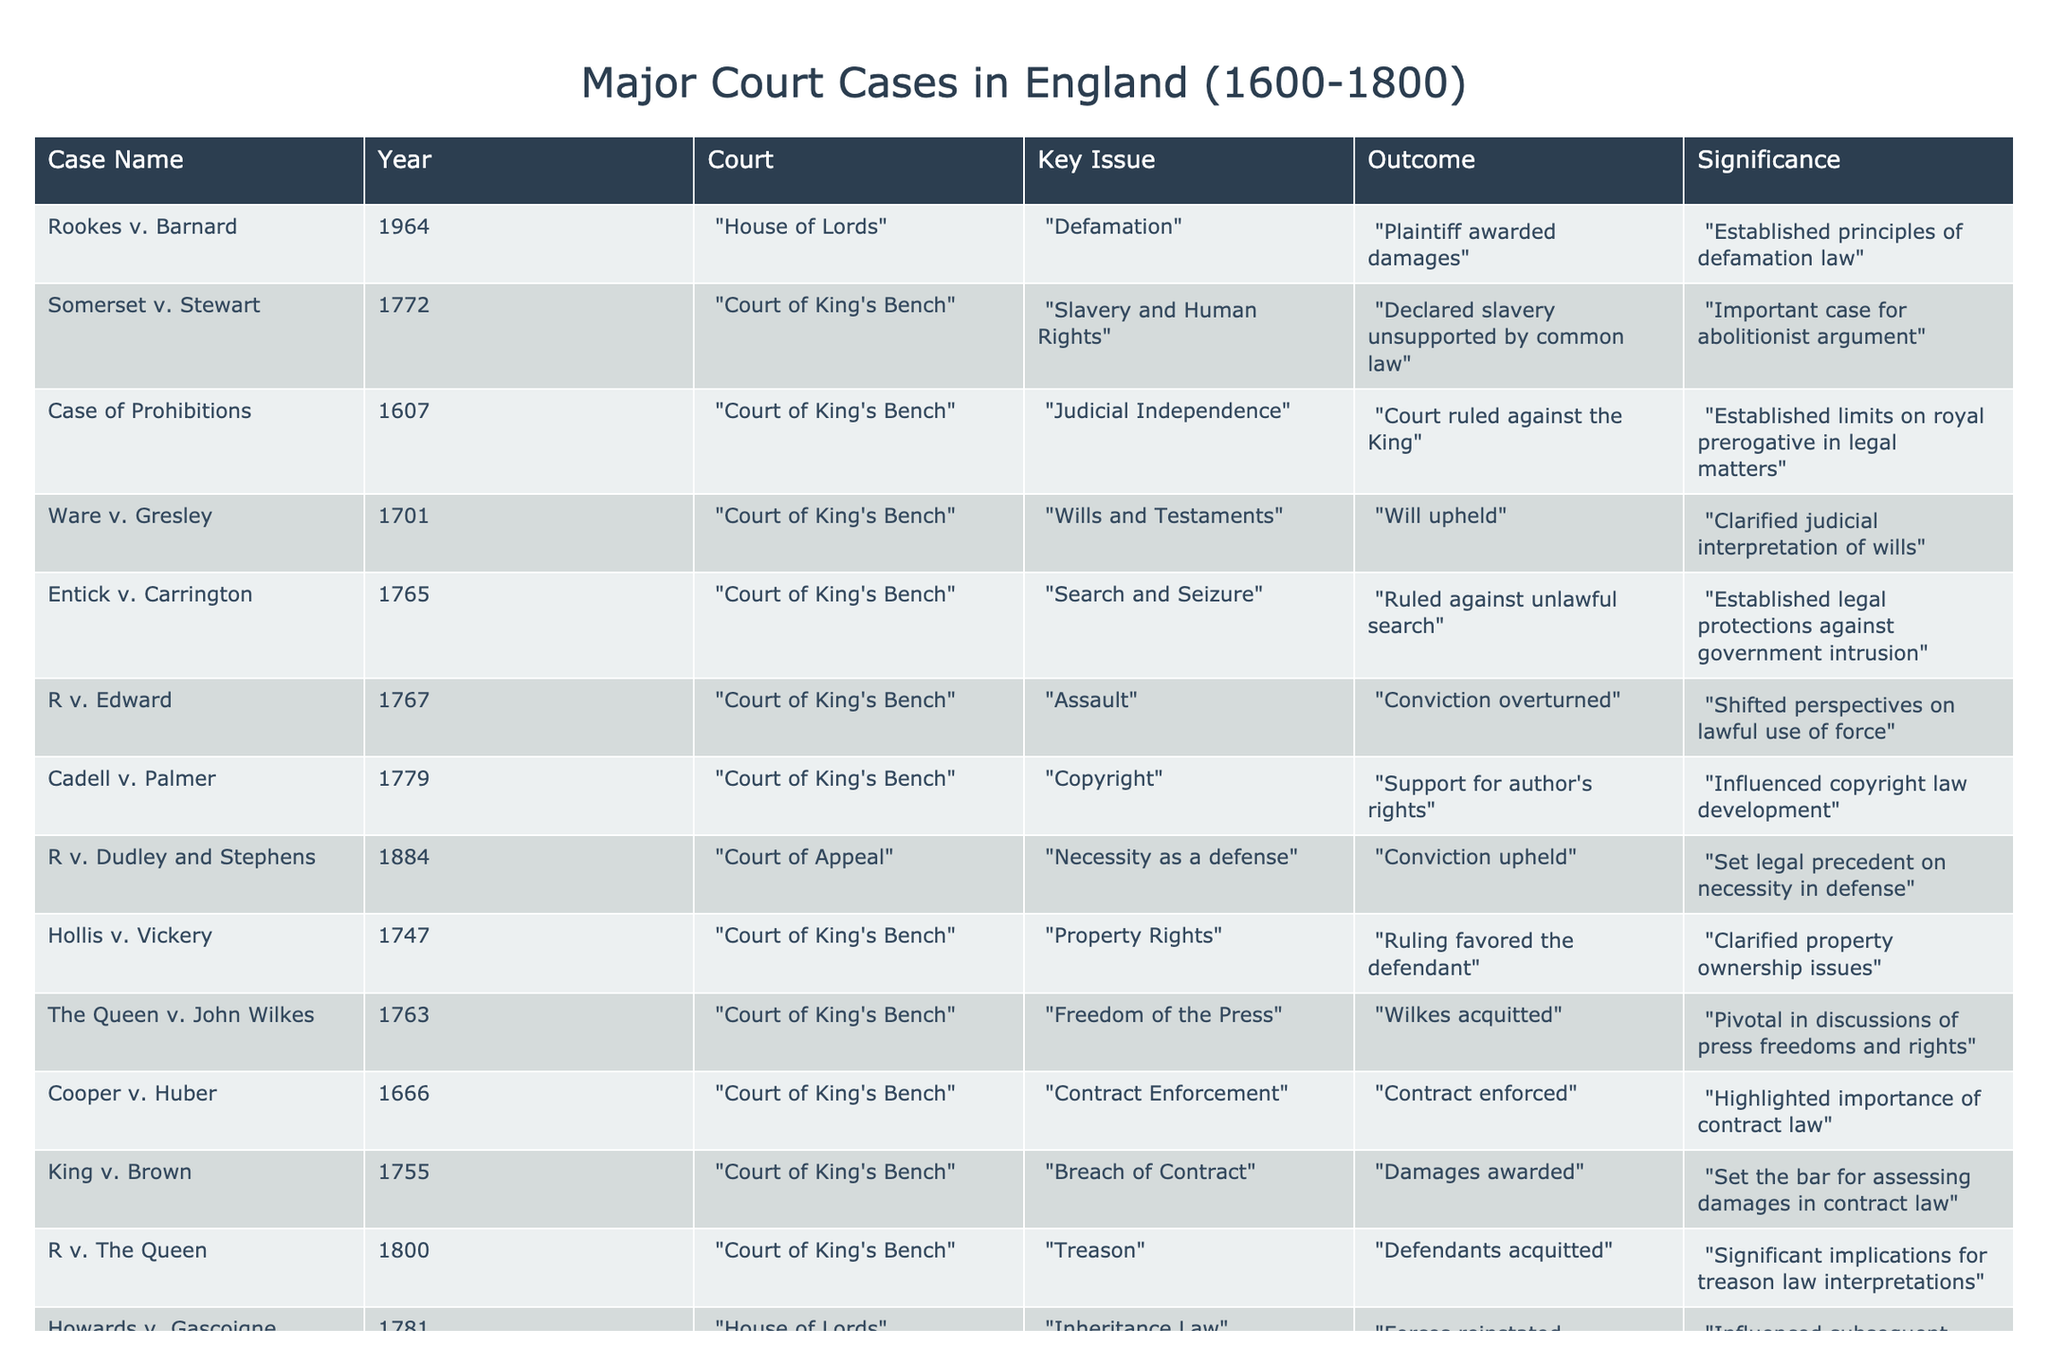What case established legal protections against unlawful searches? The outcome of "Entick v. Carrington" in 1765 ruled against unlawful searches and established legal protections, making it the case that established these protections.
Answer: Entick v. Carrington In what year was the case "Somerset v. Stewart" decided? The case "Somerset v. Stewart" was decided in the year 1772, as shown directly in the table.
Answer: 1772 Which case dealt with the breach of contract in 1755? The table lists "King v. Brown" as the case that dealt with breach of contract in 1755.
Answer: King v. Brown How many cases were decided in the Court of King's Bench? By counting the rows in the table, there are 8 cases listed from the Court of King's Bench, which are: Somerset v. Stewart, Case of Prohibitions, Ware v. Gresley, Entick v. Carrington, R v. Edward, Cadell v. Palmer, Hollis v. Vickery, and King v. Brown.
Answer: 8 Was the outcome of "Rookes v. Barnard" a conviction? Looking at the table, the outcome of "Rookes v. Barnard" was that the plaintiff was awarded damages, which means there was no conviction.
Answer: No What was the significance of "Howards v. Gascoigne" in inheritance law? The significance of "Howards v. Gascoigne," a case from 1781, is that it reinstated inheritance, influencing subsequent inheritance cases.
Answer: It reinstated inheritance Which case had a significant implication for treason law interpretations? The table indicates that "R v. The Queen" from 1800 had significant implications for interpretations of treason law, as the defendants were acquitted.
Answer: R v. The Queen What is the average year of the cases related to property rights? The cases related to property rights are "Hollis v. Vickery" (1747) and "Ware v. Gresley" (1701). The average year is calculated as (1747 + 1701) / 2 = 1724. The average year of the property rights cases is 1724.
Answer: 1724 Which case resulted in a ruling in favor of the defendant in 1747? The table lists "Hollis v. Vickery" as the case that resulted in a ruling in favor of the defendant in 1747.
Answer: Hollis v. Vickery What common theme connects the cases "Entick v. Carrington" and "The Queen v. John Wilkes"? Both cases are associated with the theme of freedoms: "Entick v. Carrington" established protections against unlawful search, while "The Queen v. John Wilkes" was pivotal in discussions of press freedoms. The connection lies in them addressing important aspects of personal freedoms.
Answer: Freedoms 